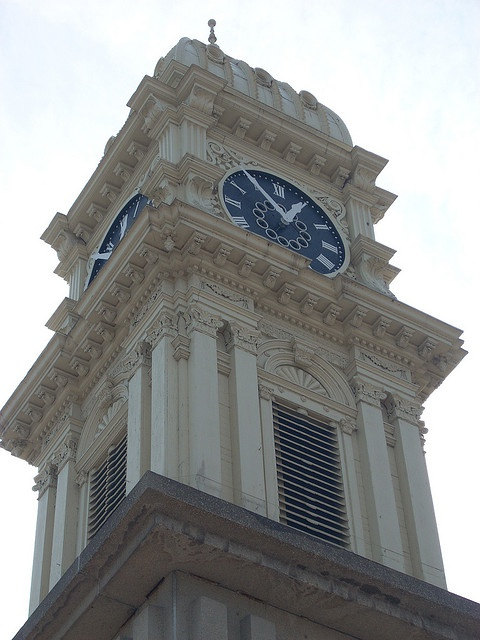Describe the objects in this image and their specific colors. I can see clock in lavender, navy, darkblue, black, and darkgray tones and clock in lavender, black, darkgray, navy, and gray tones in this image. 